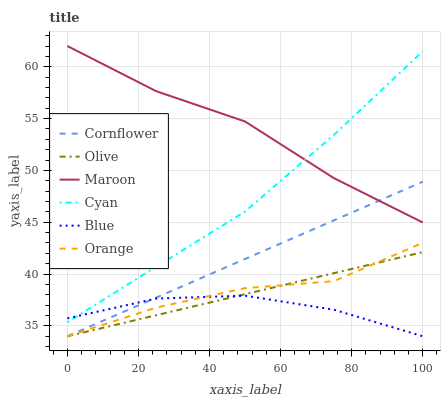Does Cornflower have the minimum area under the curve?
Answer yes or no. No. Does Cornflower have the maximum area under the curve?
Answer yes or no. No. Is Maroon the smoothest?
Answer yes or no. No. Is Cornflower the roughest?
Answer yes or no. No. Does Maroon have the lowest value?
Answer yes or no. No. Does Cornflower have the highest value?
Answer yes or no. No. Is Cornflower less than Cyan?
Answer yes or no. Yes. Is Cyan greater than Cornflower?
Answer yes or no. Yes. Does Cornflower intersect Cyan?
Answer yes or no. No. 